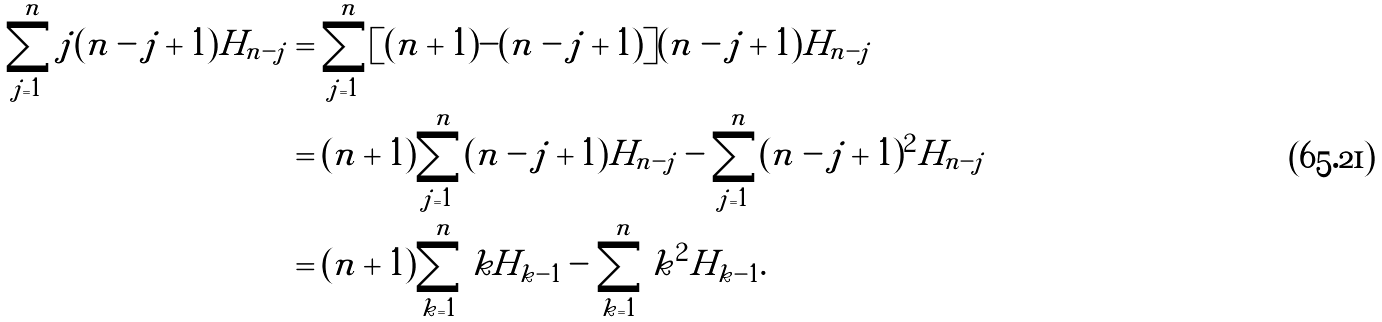<formula> <loc_0><loc_0><loc_500><loc_500>\sum _ { j = 1 } ^ { n } j ( n - j + 1 ) H _ { n - j } & = \sum _ { j = 1 } ^ { n } [ ( n + 1 ) - ( n - j + 1 ) ] ( n - j + 1 ) H _ { n - j } \\ & = ( n + 1 ) \sum _ { j = 1 } ^ { n } ( n - j + 1 ) H _ { n - j } - \sum _ { j = 1 } ^ { n } ( n - j + 1 ) ^ { 2 } H _ { n - j } \\ & = ( n + 1 ) \sum _ { k = 1 } ^ { n } k H _ { k - 1 } - \sum _ { k = 1 } ^ { n } k ^ { 2 } H _ { k - 1 } .</formula> 